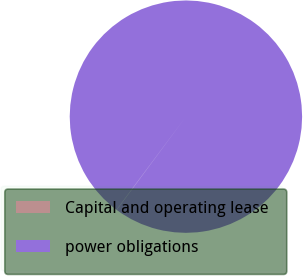Convert chart to OTSL. <chart><loc_0><loc_0><loc_500><loc_500><pie_chart><fcel>Capital and operating lease<fcel>power obligations<nl><fcel>0.03%<fcel>99.97%<nl></chart> 